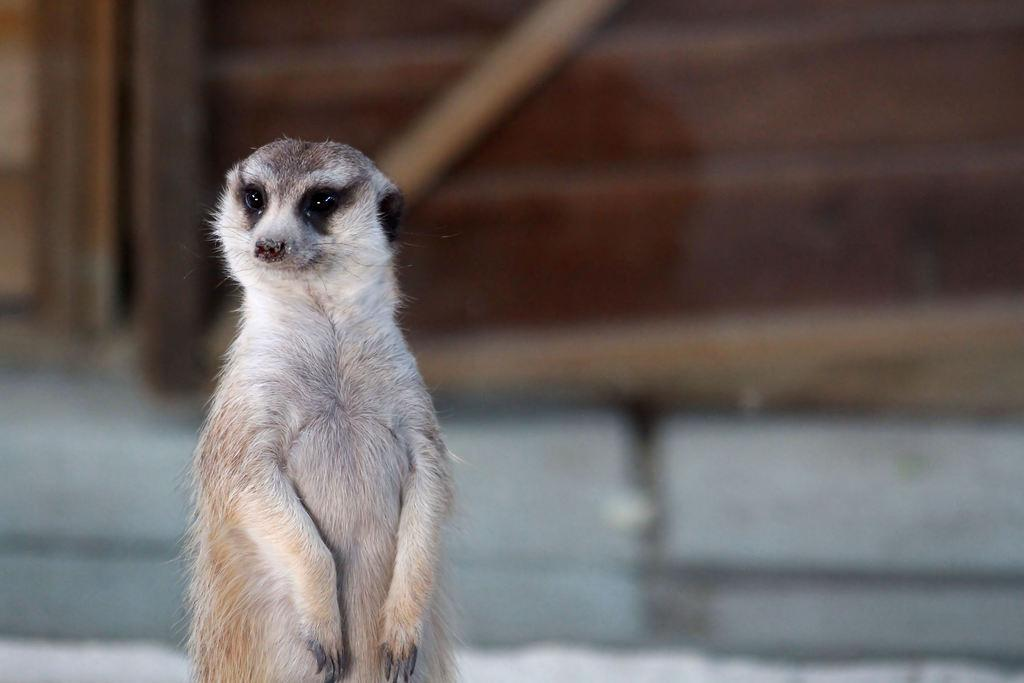What type of creature is in the image? There is an animal in the image. Can you describe the background details be identified about the animal? Yes, the animal has cream, black, white, and brown colors. How would you describe the background of the image? The background of the image is blurry. What colors are present in the background? The background colors are white and brown. What type of country is depicted in the image? There is no country depicted in the image; it features an animal with specific colors and a blurry background. How many knots are tied in the image? There are no knots present in the image. 